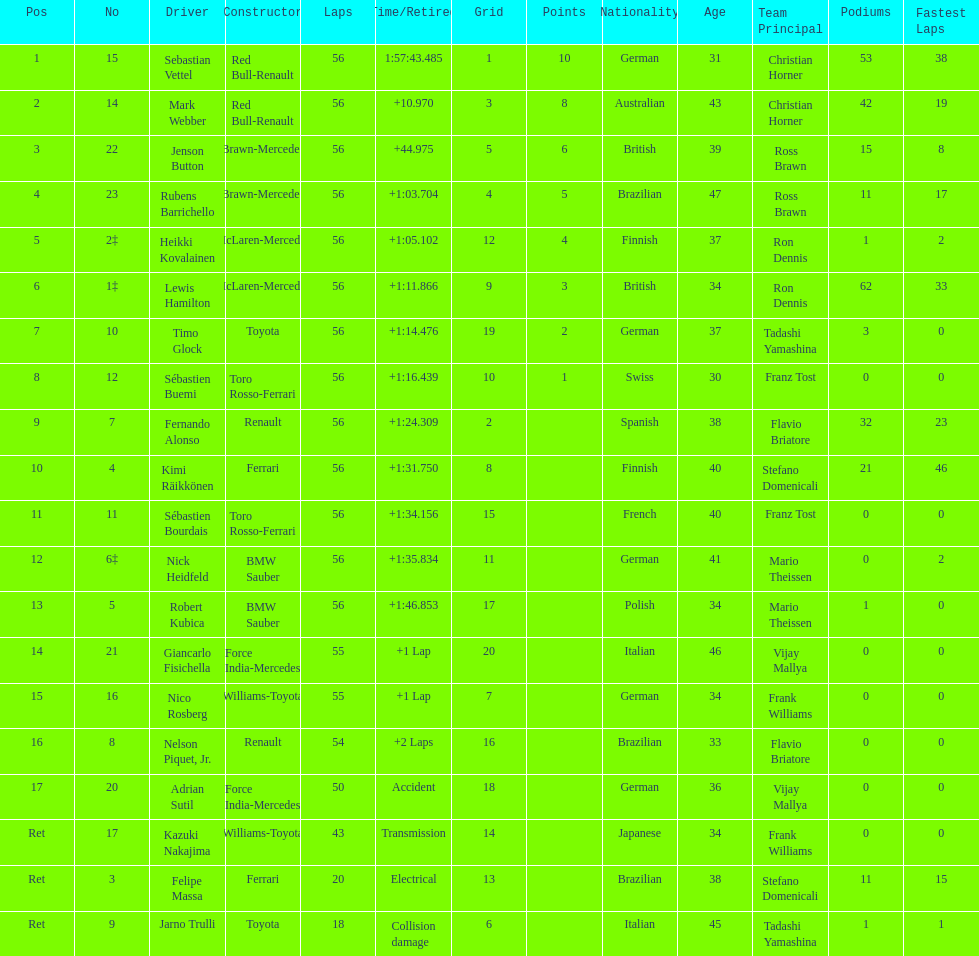What was jenson button's time? +44.975. 